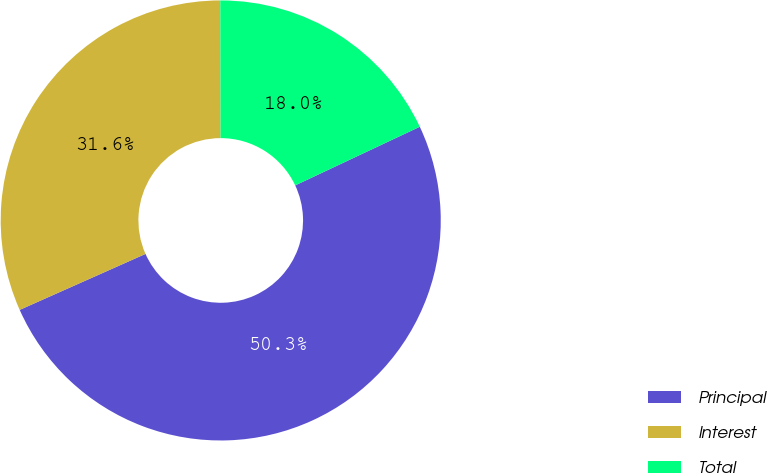<chart> <loc_0><loc_0><loc_500><loc_500><pie_chart><fcel>Principal<fcel>Interest<fcel>Total<nl><fcel>50.34%<fcel>31.63%<fcel>18.03%<nl></chart> 